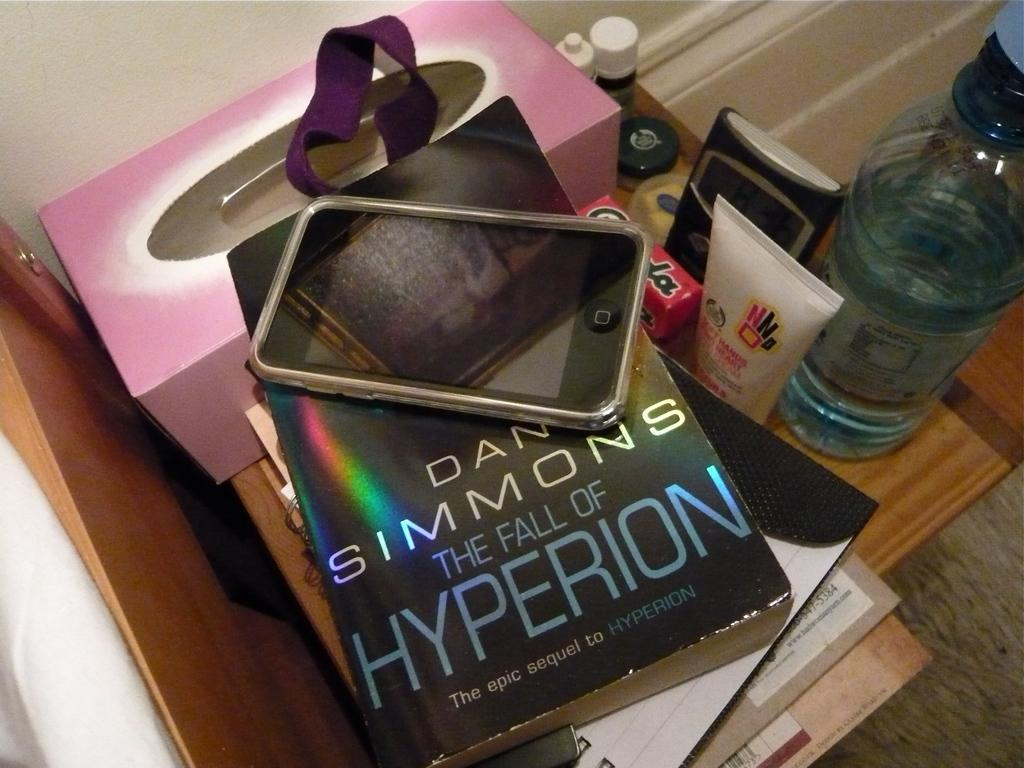What is the main piece of furniture in the image? There is a table in the image. What items can be seen on the table? There are books, a mobile, a bottle, and a box on the table. What is the background of the image? There is a wall visible in the image. Is there a spy hiding behind the wall in the image? There is no indication of a spy or any hidden figure in the image. 